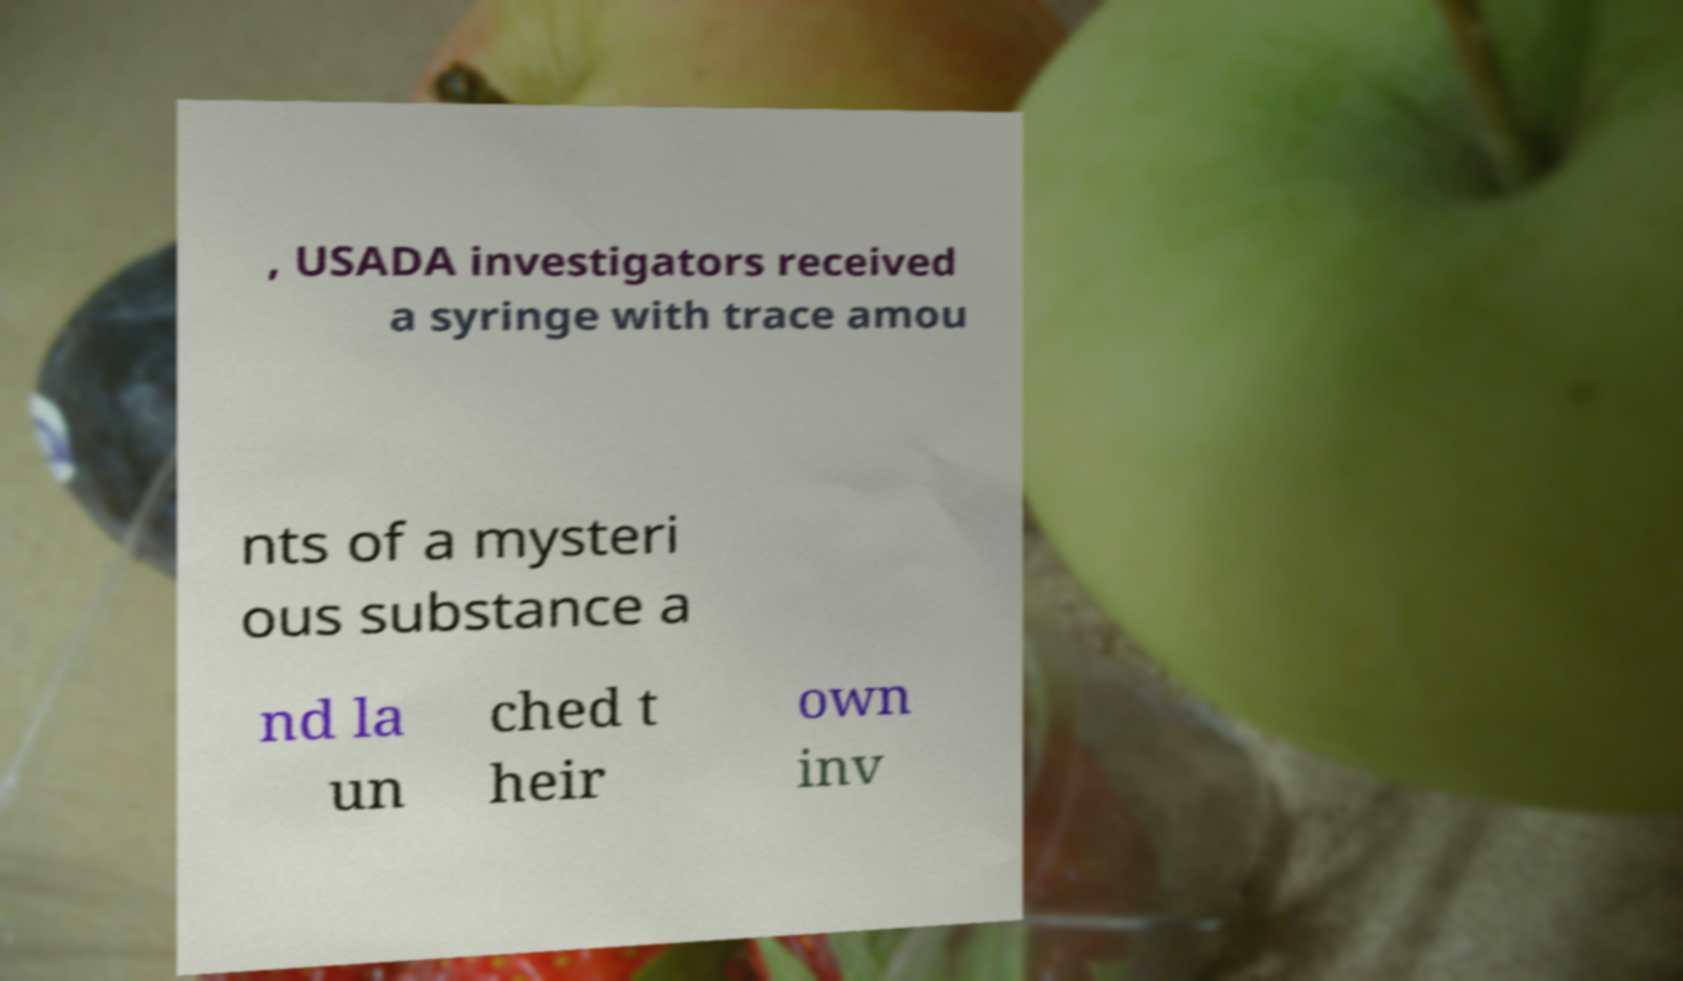What messages or text are displayed in this image? I need them in a readable, typed format. , USADA investigators received a syringe with trace amou nts of a mysteri ous substance a nd la un ched t heir own inv 